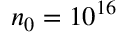<formula> <loc_0><loc_0><loc_500><loc_500>n _ { 0 } = 1 0 ^ { 1 6 }</formula> 